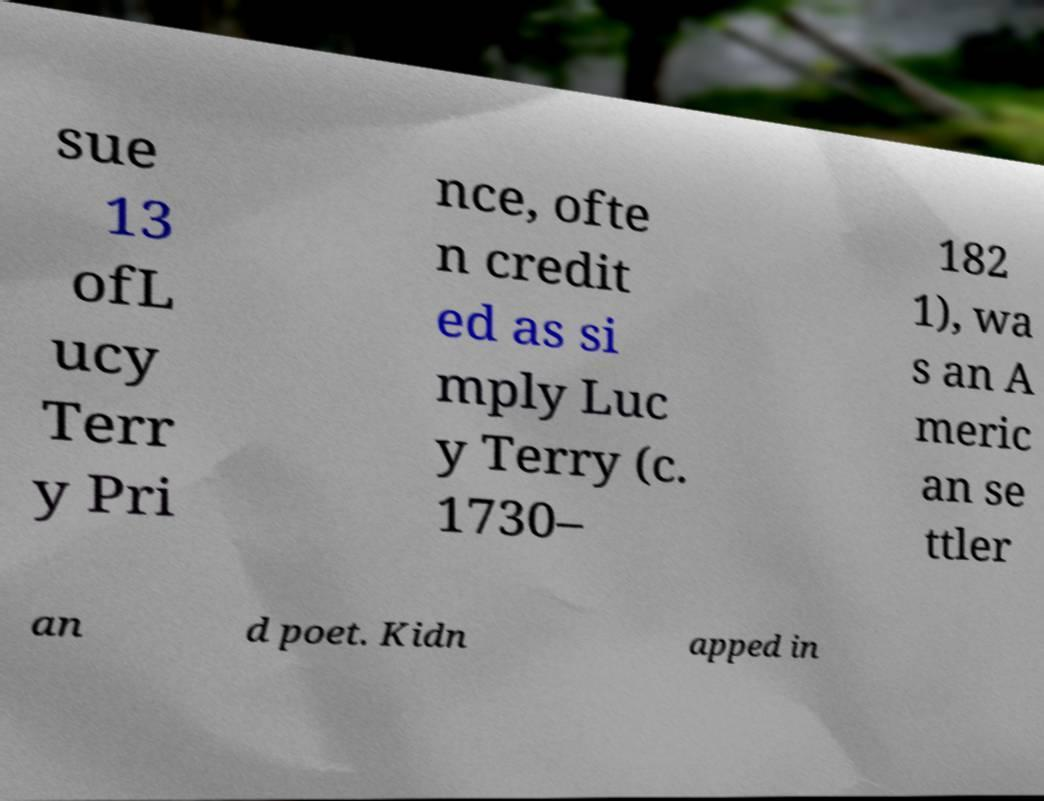I need the written content from this picture converted into text. Can you do that? sue 13 ofL ucy Terr y Pri nce, ofte n credit ed as si mply Luc y Terry (c. 1730– 182 1), wa s an A meric an se ttler an d poet. Kidn apped in 